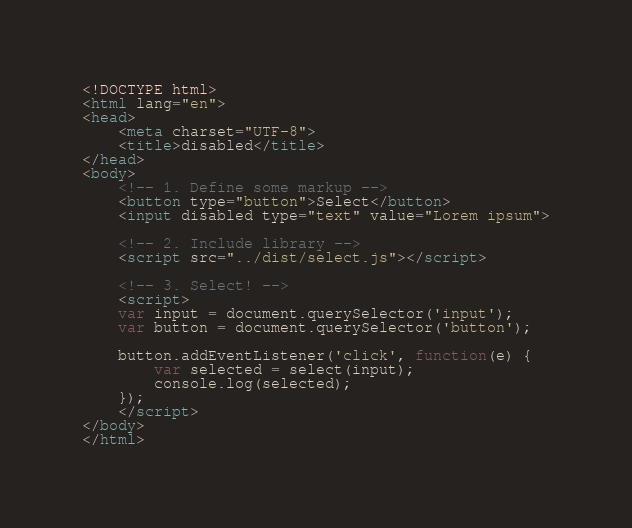Convert code to text. <code><loc_0><loc_0><loc_500><loc_500><_HTML_><!DOCTYPE html>
<html lang="en">
<head>
    <meta charset="UTF-8">
    <title>disabled</title>
</head>
<body>
    <!-- 1. Define some markup -->
    <button type="button">Select</button>
    <input disabled type="text" value="Lorem ipsum">

    <!-- 2. Include library -->
    <script src="../dist/select.js"></script>

    <!-- 3. Select! -->
    <script>
    var input = document.querySelector('input');
    var button = document.querySelector('button');

    button.addEventListener('click', function(e) {
        var selected = select(input);
        console.log(selected);
    });
    </script>
</body>
</html>
</code> 